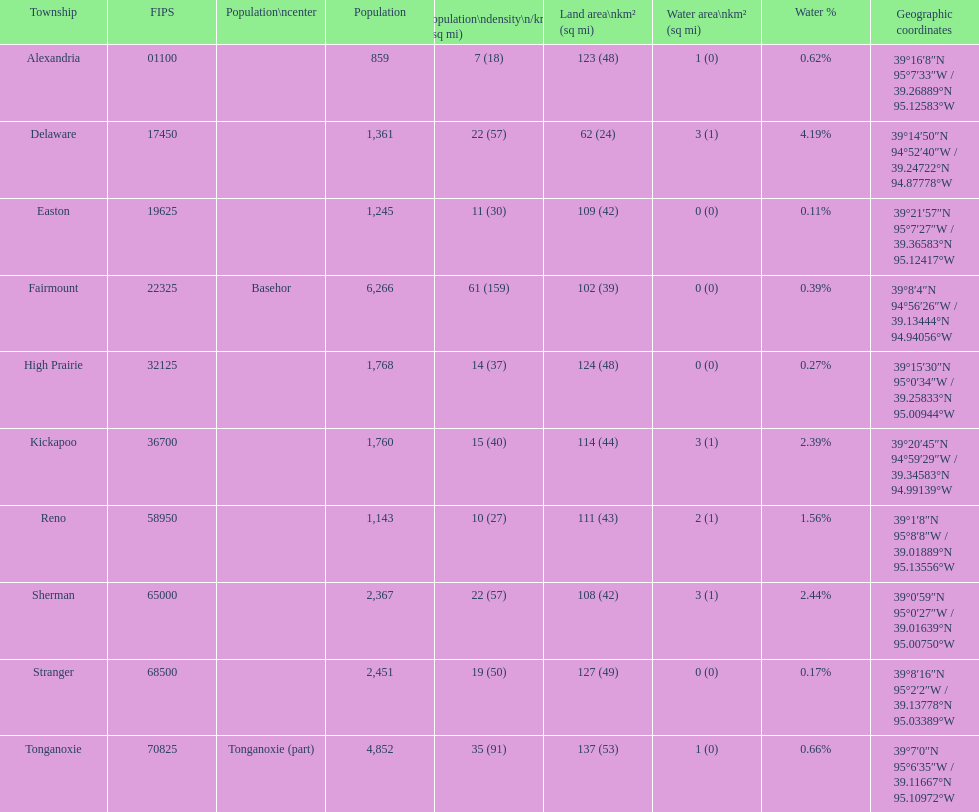What is the count of townships with a population greater than 2,000? 4. 